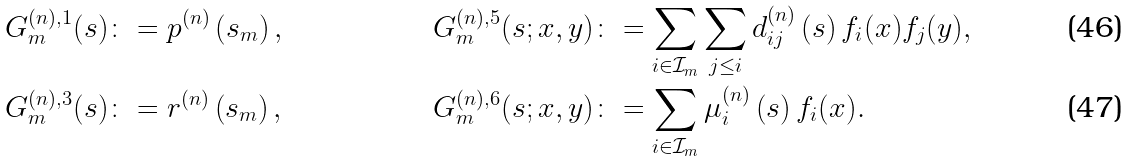<formula> <loc_0><loc_0><loc_500><loc_500>& G ^ { ( n ) , 1 } _ { m } ( s ) \colon = p ^ { ( n ) } \left ( s _ { m } \right ) , & G ^ { ( n ) , 5 } _ { m } ( s ; x , y ) & \colon = \sum _ { i \in \mathcal { I } _ { m } } \sum _ { j \leq i } d ^ { ( n ) } _ { i j } \left ( s \right ) f _ { i } ( x ) f _ { j } ( y ) , \\ & G ^ { ( n ) , 3 } _ { m } ( s ) \colon = r ^ { ( n ) } \left ( s _ { m } \right ) , & G ^ { ( n ) , 6 } _ { m } ( s ; x , y ) & \colon = \sum _ { i \in \mathcal { I } _ { m } } \mu _ { i } ^ { ( n ) } \left ( s \right ) f _ { i } ( x ) .</formula> 